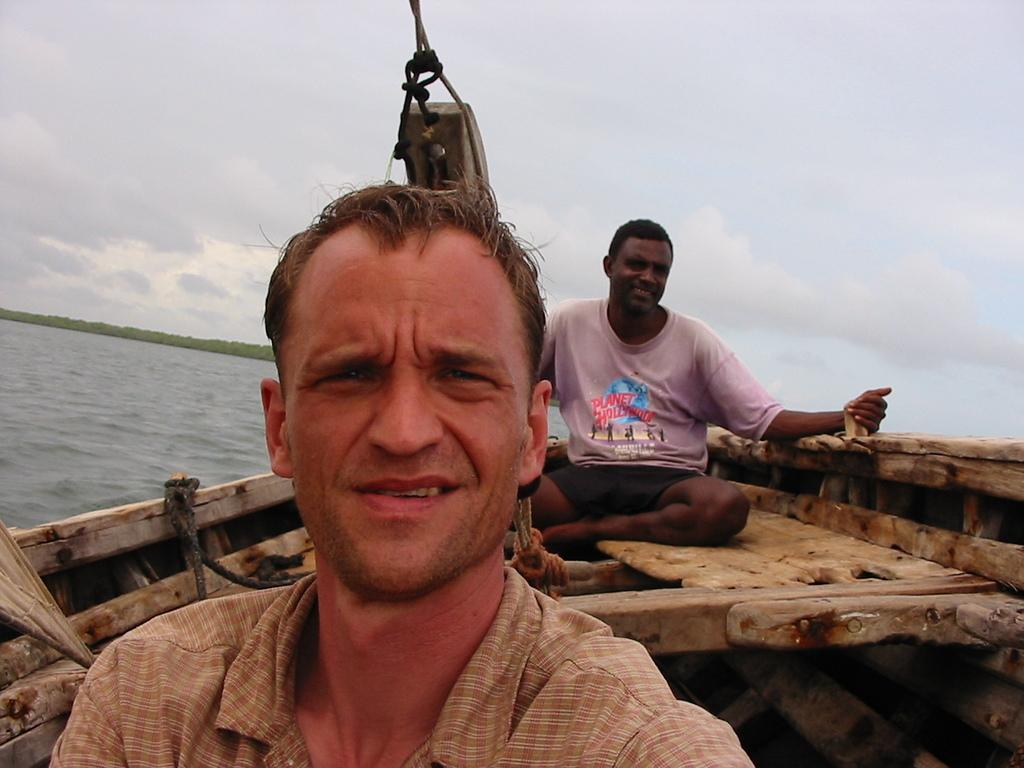What is the location of the person taking the picture? The picture is taken from a boat. How many people are in the boat? There are two men sitting in the boat. What can be seen below the boat in the image? There is water visible in the image. What type of vegetation is on the left side of the image? There is greenery on the left side of the image. What is the condition of the sky in the image? The sky is cloudy in the image. What type of scissors are the men using to cut the thread in the image? There is no scissors or thread present in the image; it features two men sitting in a boat on water with greenery and a cloudy sky. 